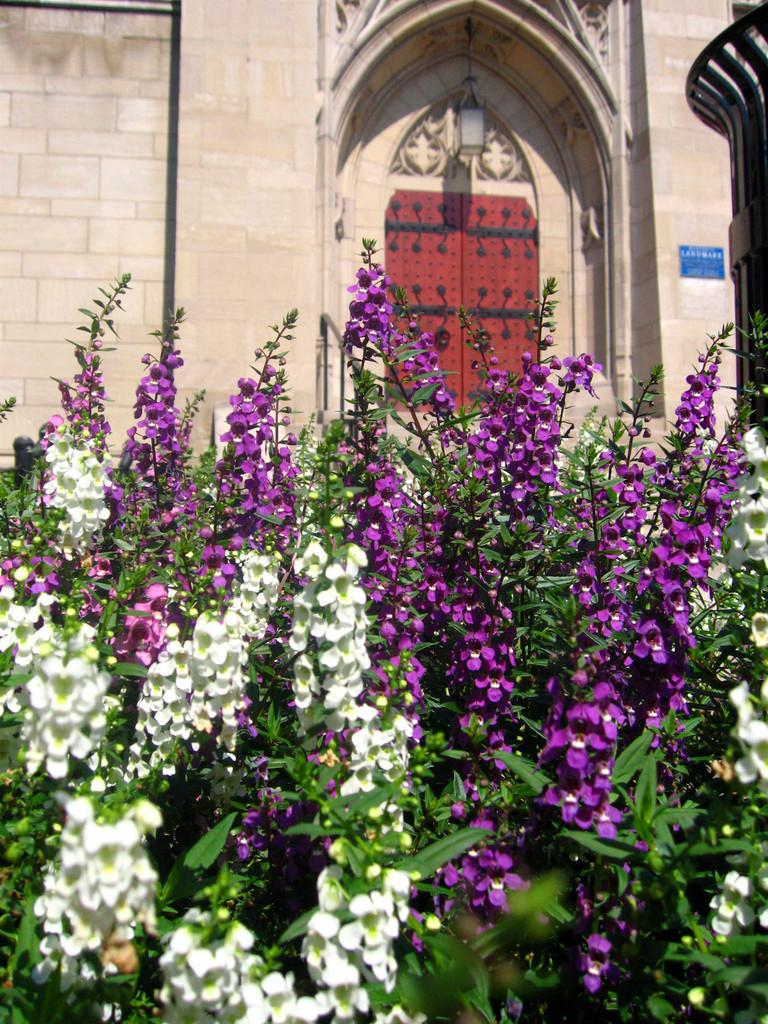What is the main structure in the image? There is a building in the image. What feature can be seen in the middle of the building? The building has doors in the middle. What type of vegetation is present in front of the building? There are flower plants in front of the building. How many yokes are hanging on the building in the image? There are no yokes present in the image. What is the amount of holiday decorations visible in the image? There is no mention of holiday decorations in the image, so it cannot be determined how many there are. 